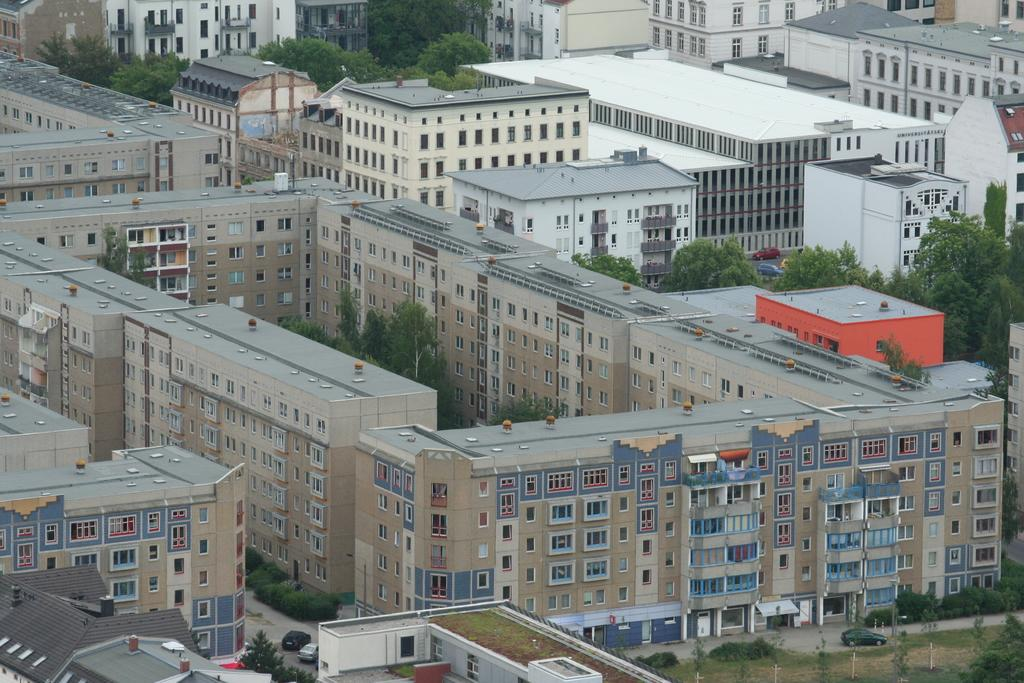What type of structures can be seen in the image? There are buildings in the image. What other natural elements are present in the image? There are trees and plants in the image. Where is the road located in the image? The road is on the right side of the image. What is happening on the road in the image? A car is moving on the road. What type of oatmeal is being served in the image? There is no oatmeal present in the image. What sound can be heard coming from the buildings in the image? The image does not provide any information about sounds, so it cannot be determined what sounds might be heard. 